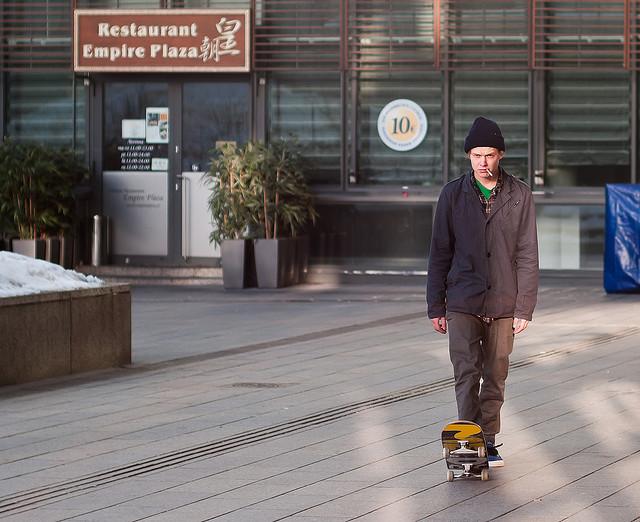Does traffic on 5th Avenue flow to the right?
Write a very short answer. No. What is on this person's left arm?
Keep it brief. Sleeve. Is the man smoking?
Answer briefly. Yes. Is the person on the skateboard wearing a helmet?
Answer briefly. No. How many skateboards can be seen?
Give a very brief answer. 1. What color is prominent on the bottom of this person's skateboard?
Write a very short answer. Yellow. What color is the sign?
Quick response, please. Brown. Is the man standing in grass?
Be succinct. No. Is there a cab in the picture?
Be succinct. No. 